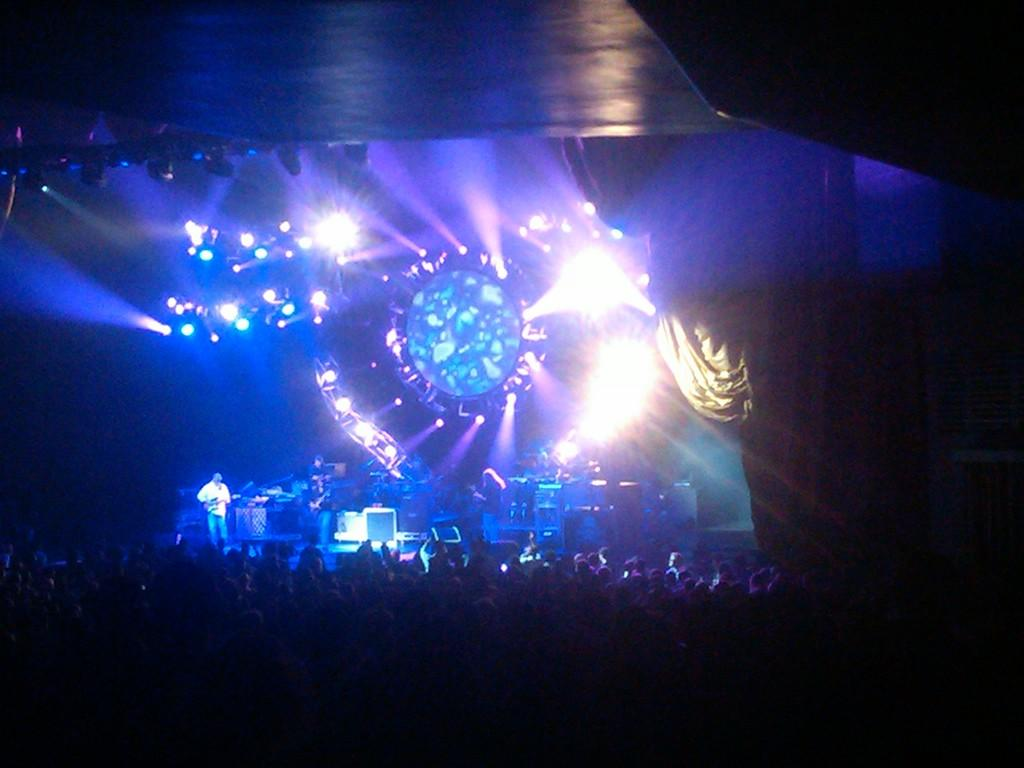What event is taking place in the image? There is a concert in the image. Where are the people located in the image? There is a crowd at the bottom of the image. What can be seen in the middle of the image? There are lights in the middle of the image. How many giraffes can be seen in the image? There are no giraffes present in the image. What type of blade is being used by the performers on stage? There is no blade visible in the image, and no indication that performers are using any blades. 